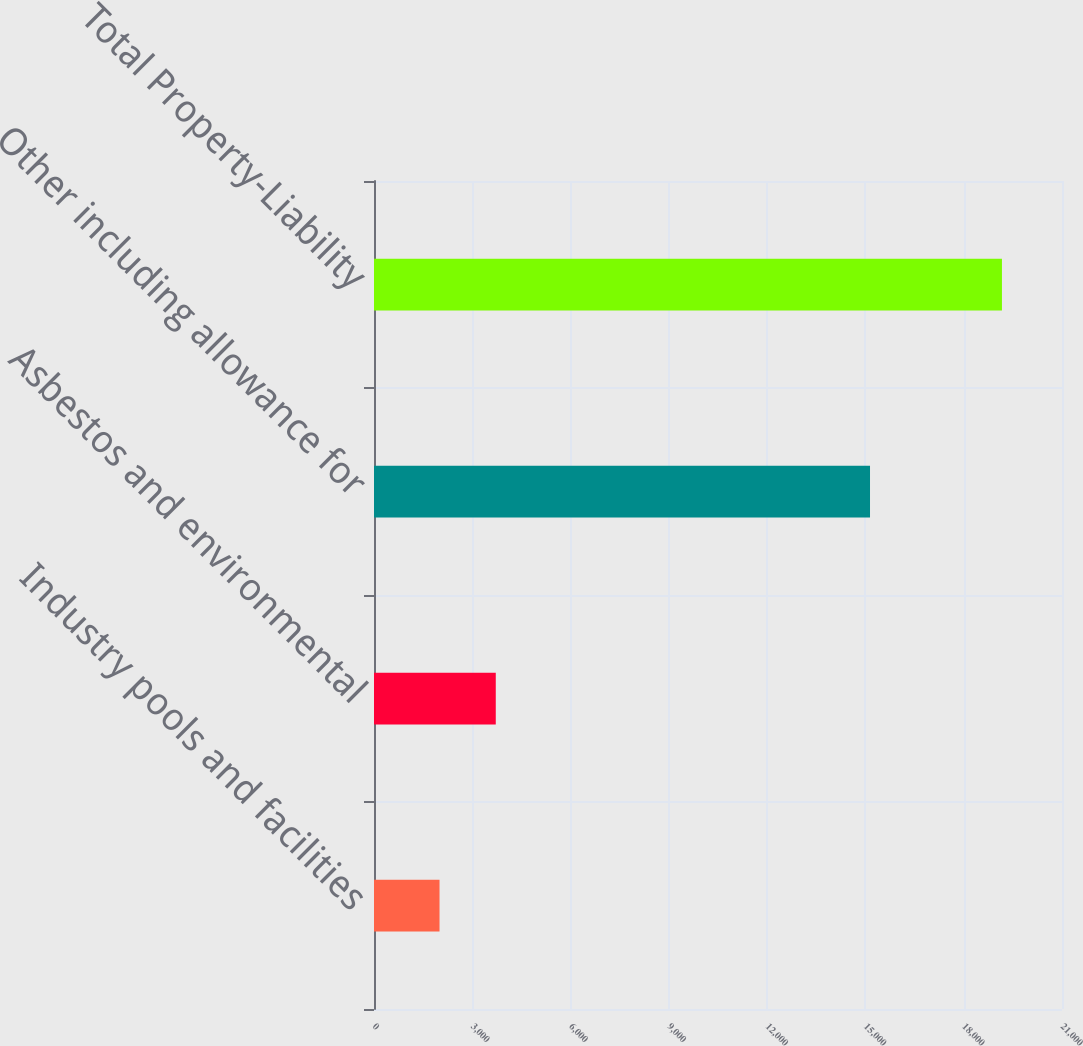Convert chart to OTSL. <chart><loc_0><loc_0><loc_500><loc_500><bar_chart><fcel>Industry pools and facilities<fcel>Asbestos and environmental<fcel>Other including allowance for<fcel>Total Property-Liability<nl><fcel>2000<fcel>3716.7<fcel>15140<fcel>19167<nl></chart> 